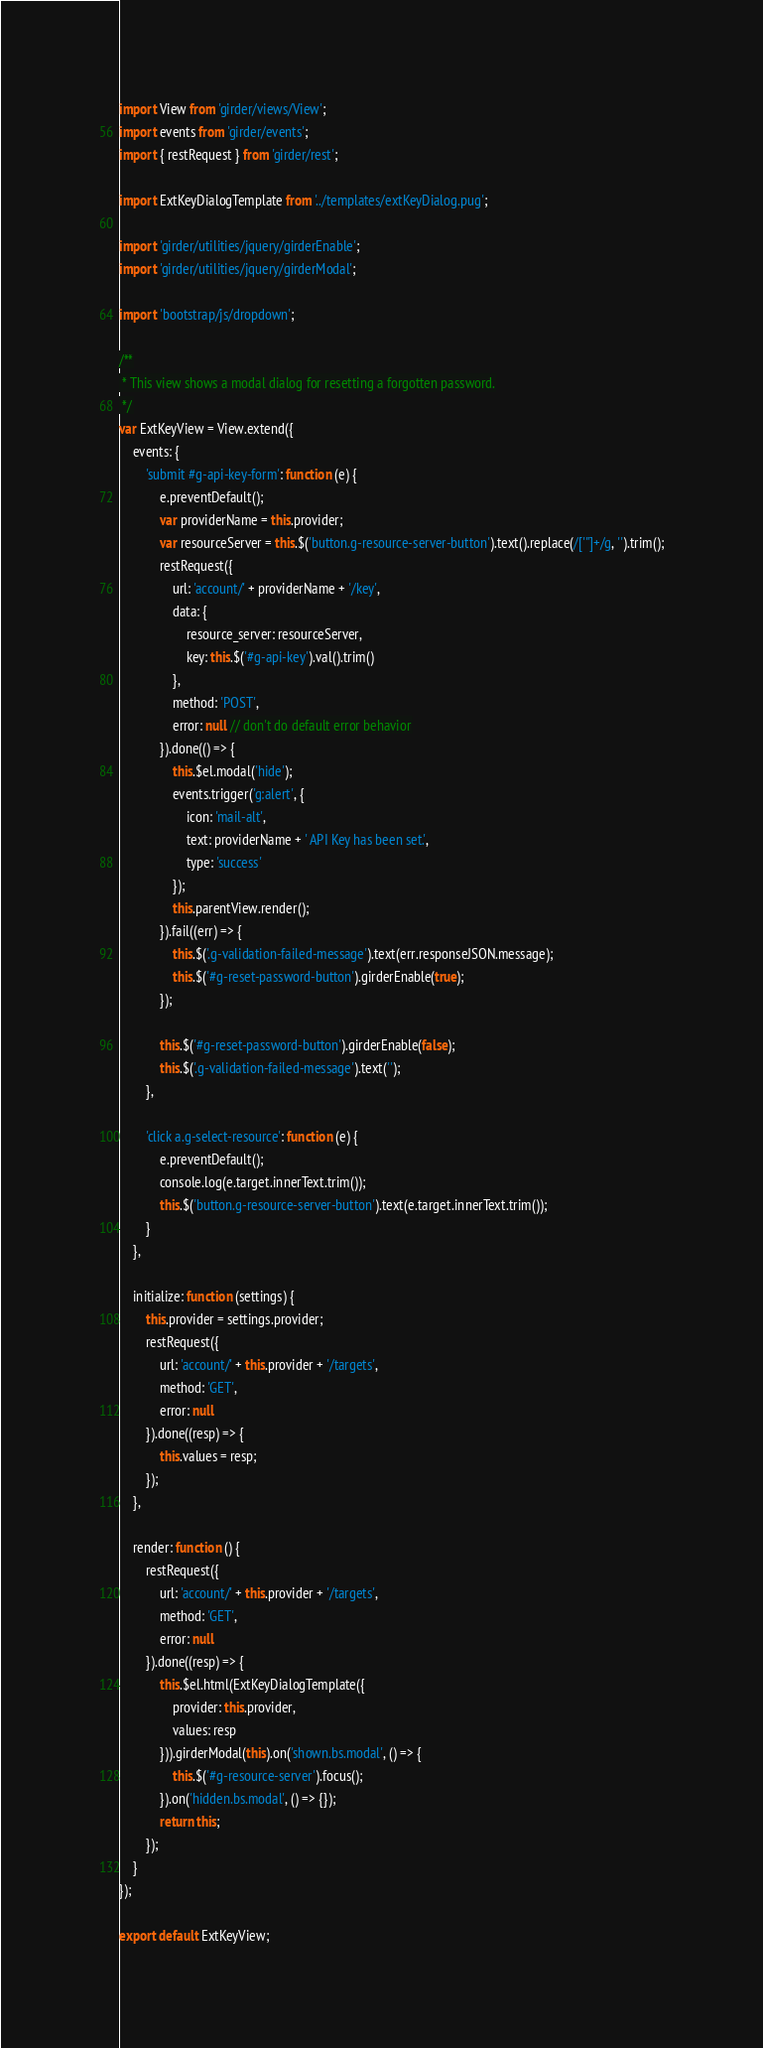Convert code to text. <code><loc_0><loc_0><loc_500><loc_500><_JavaScript_>import View from 'girder/views/View';
import events from 'girder/events';
import { restRequest } from 'girder/rest';

import ExtKeyDialogTemplate from '../templates/extKeyDialog.pug';

import 'girder/utilities/jquery/girderEnable';
import 'girder/utilities/jquery/girderModal';

import 'bootstrap/js/dropdown';

/**
 * This view shows a modal dialog for resetting a forgotten password.
 */
var ExtKeyView = View.extend({
    events: {
        'submit #g-api-key-form': function (e) {
            e.preventDefault();
            var providerName = this.provider;
            var resourceServer = this.$('button.g-resource-server-button').text().replace(/['"]+/g, '').trim();
            restRequest({
                url: 'account/' + providerName + '/key',
                data: {
                    resource_server: resourceServer,
                    key: this.$('#g-api-key').val().trim()
                },
                method: 'POST',
                error: null // don't do default error behavior
            }).done(() => {
                this.$el.modal('hide');
                events.trigger('g:alert', {
                    icon: 'mail-alt',
                    text: providerName + ' API Key has been set.',
                    type: 'success'
                });
                this.parentView.render();
            }).fail((err) => {
                this.$('.g-validation-failed-message').text(err.responseJSON.message);
                this.$('#g-reset-password-button').girderEnable(true);
            });

            this.$('#g-reset-password-button').girderEnable(false);
            this.$('.g-validation-failed-message').text('');
        },

        'click a.g-select-resource': function (e) {
            e.preventDefault();
            console.log(e.target.innerText.trim());
            this.$('button.g-resource-server-button').text(e.target.innerText.trim());
        }
    },

    initialize: function (settings) {
        this.provider = settings.provider;
        restRequest({
            url: 'account/' + this.provider + '/targets',
            method: 'GET',
            error: null
        }).done((resp) => {
            this.values = resp;
        });
    },

    render: function () {
        restRequest({
            url: 'account/' + this.provider + '/targets',
            method: 'GET',
            error: null
        }).done((resp) => {
            this.$el.html(ExtKeyDialogTemplate({
                provider: this.provider,
                values: resp
            })).girderModal(this).on('shown.bs.modal', () => {
                this.$('#g-resource-server').focus();
            }).on('hidden.bs.modal', () => {});
            return this;
        });
    }
});

export default ExtKeyView;
</code> 